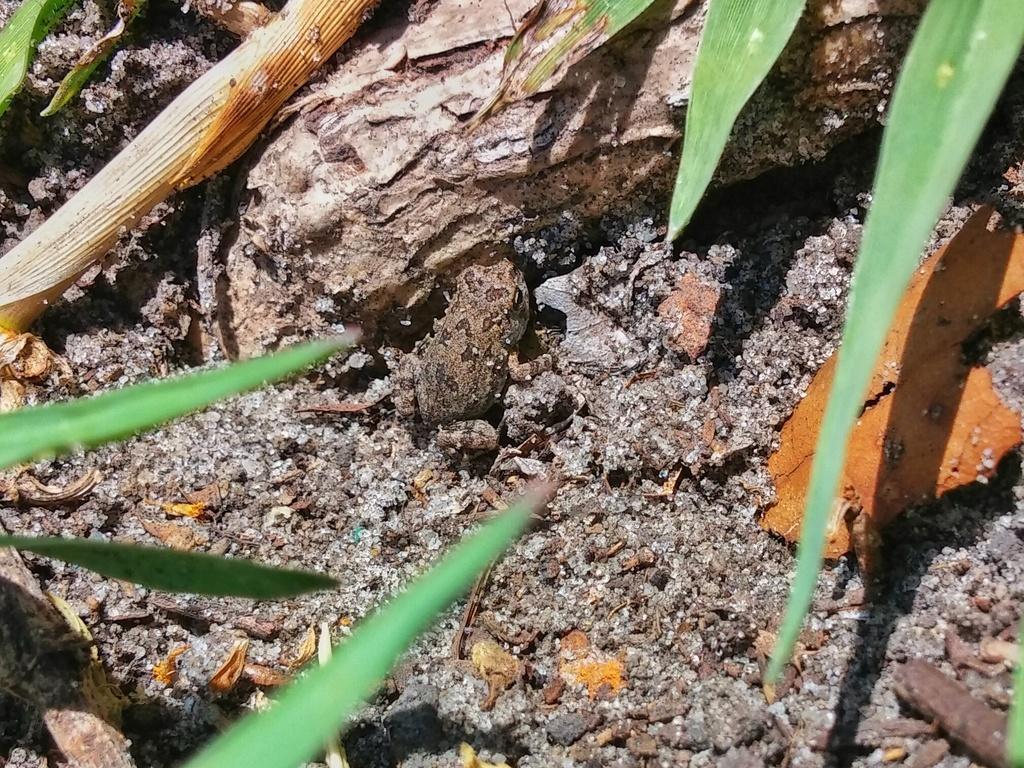In one or two sentences, can you explain what this image depicts? In this picture we can see a frog, leaves and some objects. 